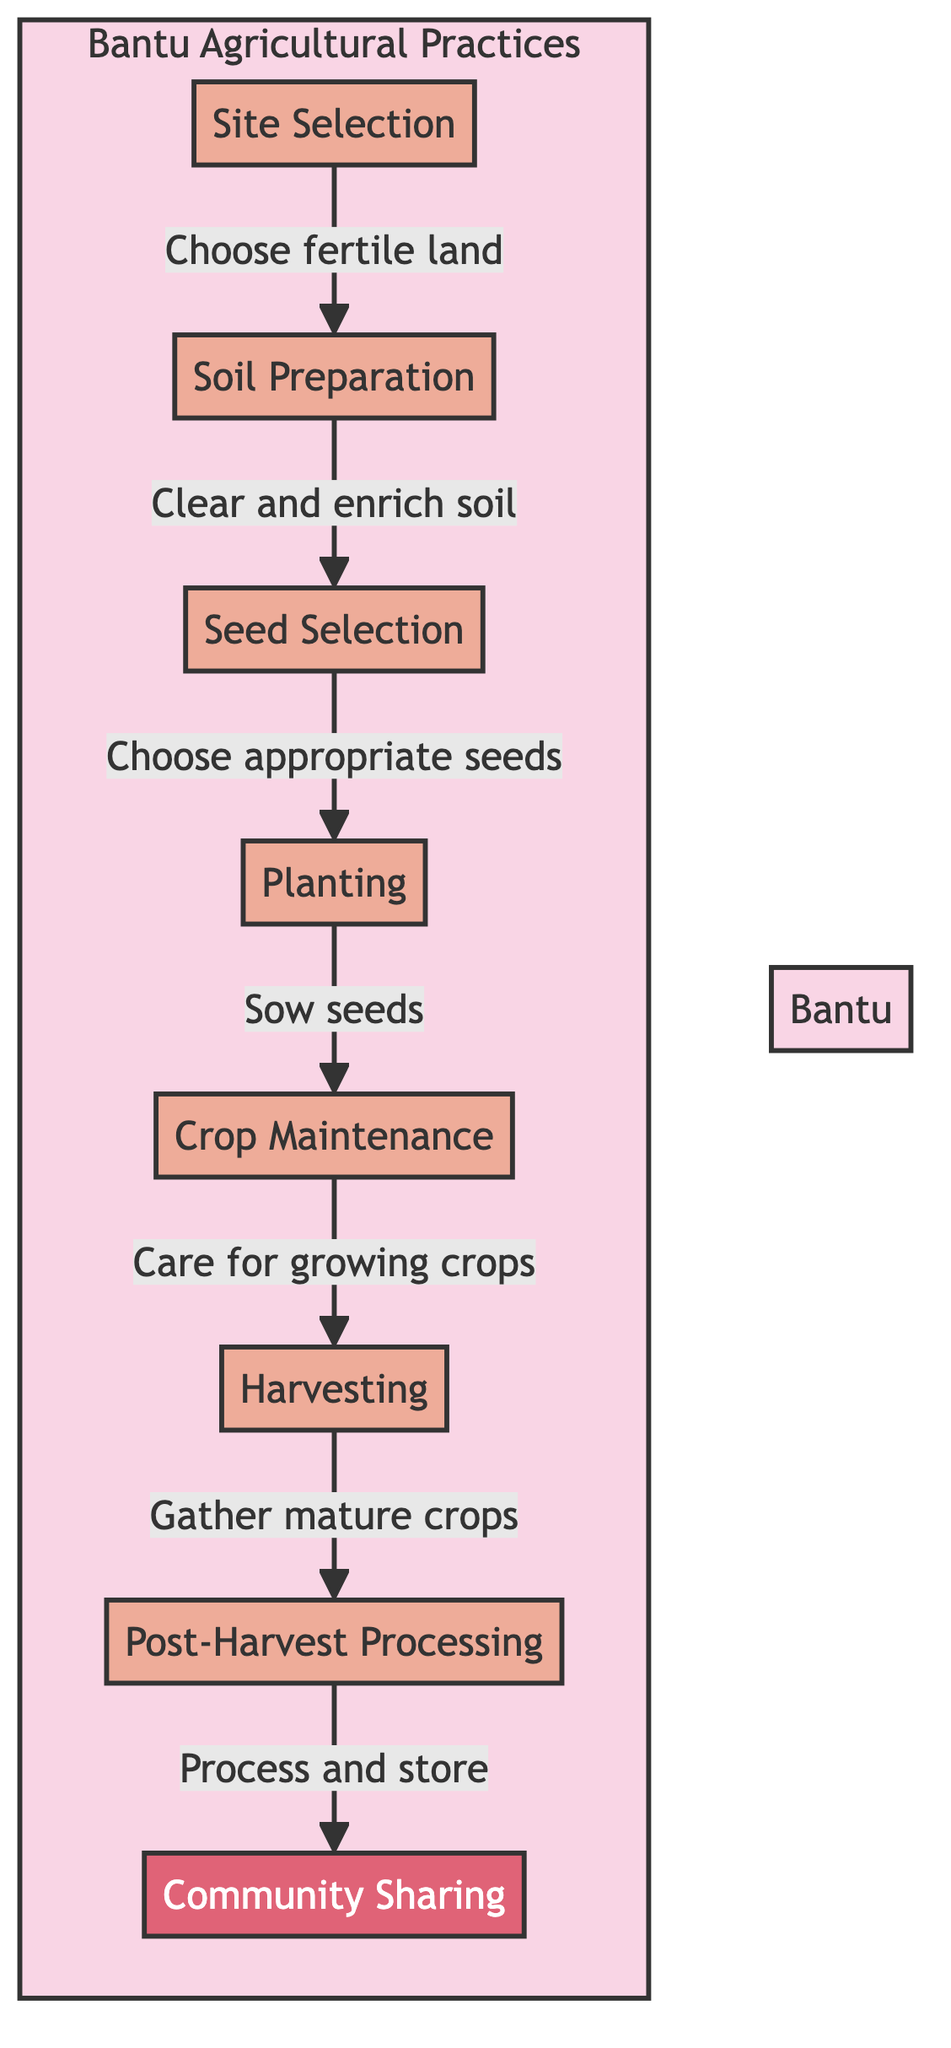What is the first step in the Bantu agricultural practices? The first step in the flow chart is "Site Selection," which indicates the process starts by choosing fertile land.
Answer: Site Selection How many total steps are there in the Bantu agricultural processes? By counting the nodes in the flow chart, we find there are eight distinct steps listed, which include Site Selection, Soil Preparation, Seed Selection, Planting, Crop Maintenance, Harvesting, Post-Harvest Processing, and Community Sharing.
Answer: Eight What is the final process in the flow chart? The last step in the diagram is "Community Sharing," which emphasizes the redistribution of surplus crops among community members.
Answer: Community Sharing What relationship exists between Soil Preparation and Seed Selection? According to the diagram, Soil Preparation leads to Seed Selection, indicating that soil preparation is necessary before selecting seeds.
Answer: Leads to What do the nodes from Planting to Harvesting collectively represent? The nodes from Planting through Harvesting outline the core cultivation phase in agriculture, focusing on the growing of crops from sowing to gathering them at maturity.
Answer: Core cultivation phase How does Crop Maintenance relate to Planting? "Crop Maintenance" follows directly after "Planting" in the flow, meaning that after planting seeds, the next essential step is to maintain the crops during their growth period.
Answer: Directly follows Identify two major processes involved in the post-harvest stage. The diagram shows that "Drying" and "Storing" are part of the "Post-Harvest Processing," indicating these are key tasks after harvesting crops.
Answer: Drying, Storing What action is performed after Harvesting? Immediately following Harvesting in the diagram is "Post-Harvest Processing," suggesting that after the crops are gathered, processing occurs.
Answer: Post-Harvest Processing Which step emphasizes the community aspect of Bantu agricultural practices? "Community Sharing" highlights the importance of resource sharing within the community after harvest, addressing food security among its members.
Answer: Community Sharing 